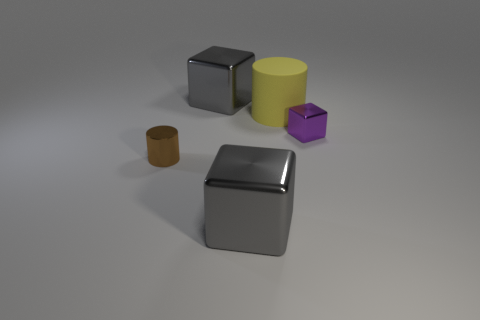Add 2 big green cubes. How many objects exist? 7 Subtract all cylinders. How many objects are left? 3 Add 2 big things. How many big things exist? 5 Subtract 0 cyan balls. How many objects are left? 5 Subtract all cyan shiny cubes. Subtract all yellow objects. How many objects are left? 4 Add 5 tiny metallic blocks. How many tiny metallic blocks are left? 6 